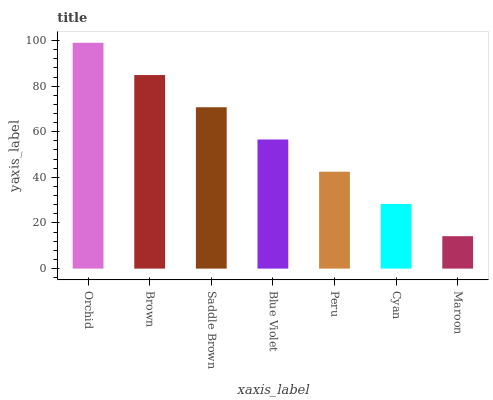Is Maroon the minimum?
Answer yes or no. Yes. Is Orchid the maximum?
Answer yes or no. Yes. Is Brown the minimum?
Answer yes or no. No. Is Brown the maximum?
Answer yes or no. No. Is Orchid greater than Brown?
Answer yes or no. Yes. Is Brown less than Orchid?
Answer yes or no. Yes. Is Brown greater than Orchid?
Answer yes or no. No. Is Orchid less than Brown?
Answer yes or no. No. Is Blue Violet the high median?
Answer yes or no. Yes. Is Blue Violet the low median?
Answer yes or no. Yes. Is Maroon the high median?
Answer yes or no. No. Is Saddle Brown the low median?
Answer yes or no. No. 